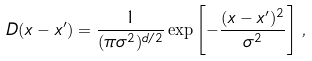<formula> <loc_0><loc_0><loc_500><loc_500>D ( { x } - { x } ^ { \prime } ) = \frac { 1 } { ( { \pi \sigma ^ { 2 } } ) ^ { d / 2 } } \exp \left [ - \frac { ( { x } - { x } ^ { \prime } ) ^ { 2 } } { \sigma ^ { 2 } } \right ] \, ,</formula> 